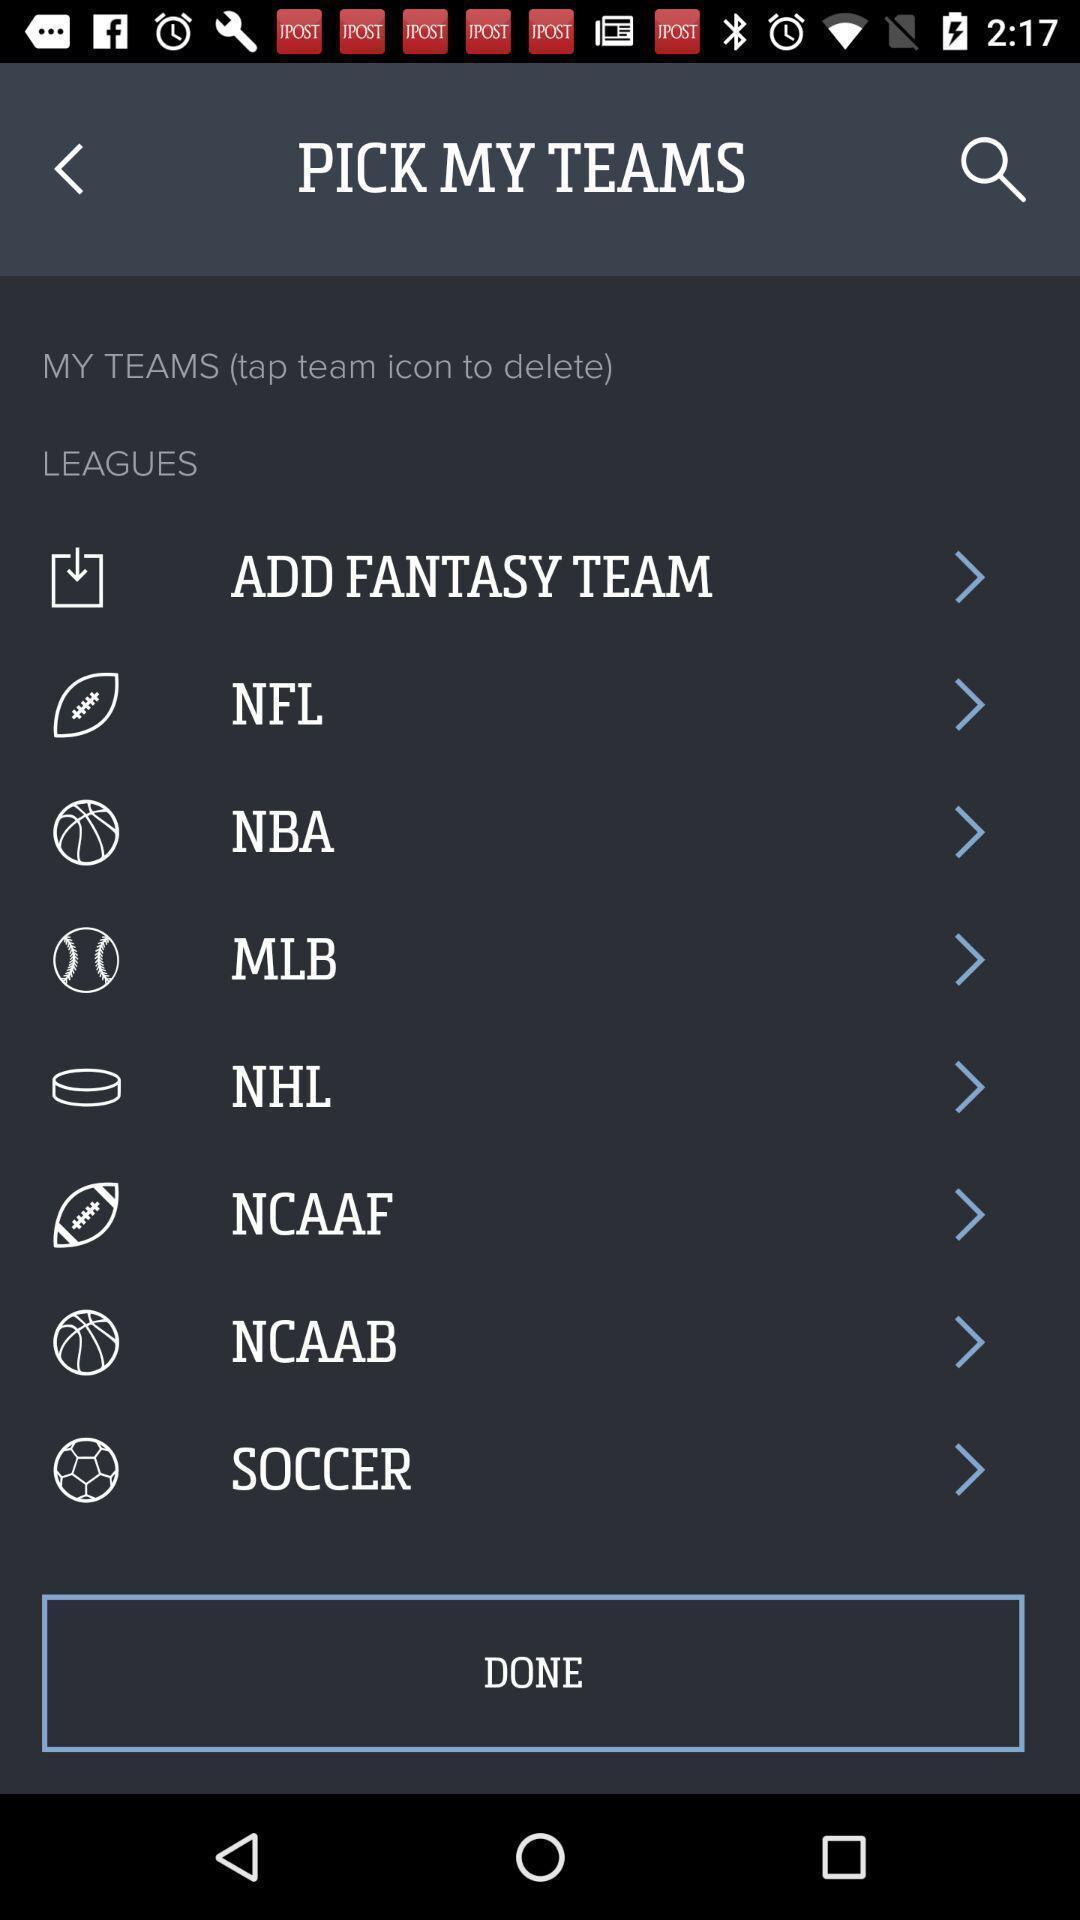Explain what's happening in this screen capture. Screen displaying multiple basketball league names. 